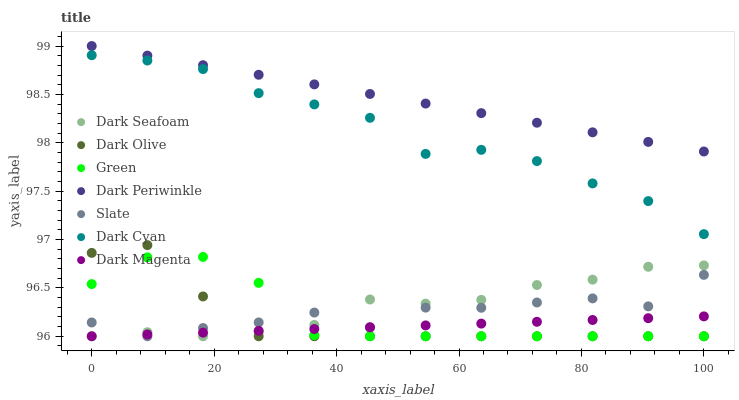Does Dark Magenta have the minimum area under the curve?
Answer yes or no. Yes. Does Dark Periwinkle have the maximum area under the curve?
Answer yes or no. Yes. Does Slate have the minimum area under the curve?
Answer yes or no. No. Does Slate have the maximum area under the curve?
Answer yes or no. No. Is Dark Magenta the smoothest?
Answer yes or no. Yes. Is Slate the roughest?
Answer yes or no. Yes. Is Dark Olive the smoothest?
Answer yes or no. No. Is Dark Olive the roughest?
Answer yes or no. No. Does Dark Magenta have the lowest value?
Answer yes or no. Yes. Does Dark Cyan have the lowest value?
Answer yes or no. No. Does Dark Periwinkle have the highest value?
Answer yes or no. Yes. Does Slate have the highest value?
Answer yes or no. No. Is Green less than Dark Cyan?
Answer yes or no. Yes. Is Dark Periwinkle greater than Dark Magenta?
Answer yes or no. Yes. Does Dark Olive intersect Slate?
Answer yes or no. Yes. Is Dark Olive less than Slate?
Answer yes or no. No. Is Dark Olive greater than Slate?
Answer yes or no. No. Does Green intersect Dark Cyan?
Answer yes or no. No. 